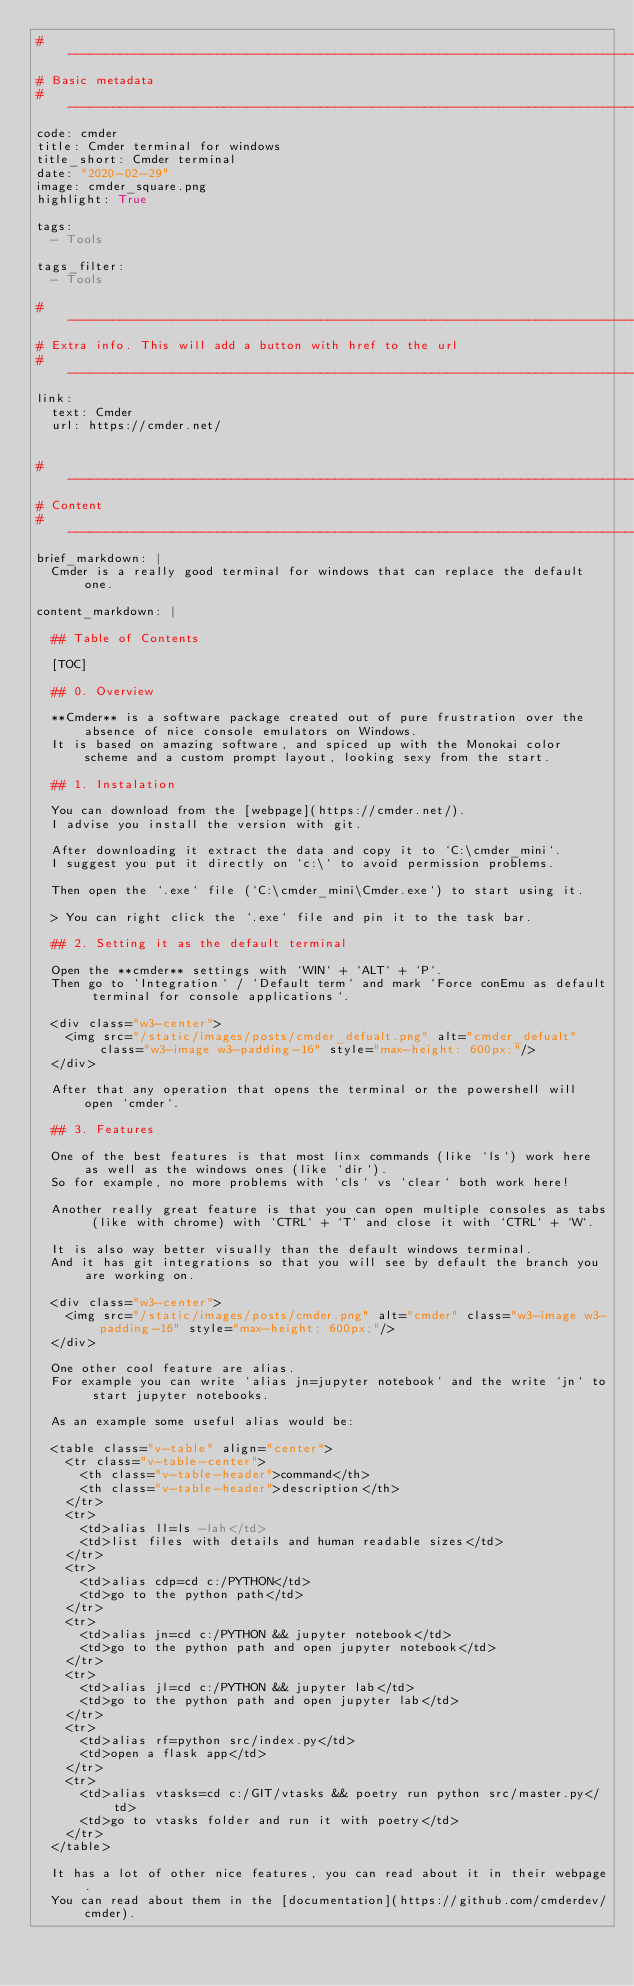Convert code to text. <code><loc_0><loc_0><loc_500><loc_500><_YAML_># --------------------------------------------------------------------------------------------------
# Basic metadata
# --------------------------------------------------------------------------------------------------
code: cmder
title: Cmder terminal for windows
title_short: Cmder terminal
date: "2020-02-29"
image: cmder_square.png
highlight: True

tags:
  - Tools

tags_filter:
  - Tools

# --------------------------------------------------------------------------------------------------
# Extra info. This will add a button with href to the url
# --------------------------------------------------------------------------------------------------
link: 
  text: Cmder
  url: https://cmder.net/


# --------------------------------------------------------------------------------------------------
# Content
# --------------------------------------------------------------------------------------------------
brief_markdown: |
  Cmder is a really good terminal for windows that can replace the default one.

content_markdown: |

  ## Table of Contents

  [TOC]

  ## 0. Overview
  
  **Cmder** is a software package created out of pure frustration over the absence of nice console emulators on Windows.
  It is based on amazing software, and spiced up with the Monokai color scheme and a custom prompt layout, looking sexy from the start.

  ## 1. Instalation

  You can download from the [webpage](https://cmder.net/).
  I advise you install the version with git.

  After downloading it extract the data and copy it to `C:\cmder_mini`.
  I suggest you put it directly on `c:\` to avoid permission problems.

  Then open the `.exe` file (`C:\cmder_mini\Cmder.exe`) to start using it.

  > You can right click the `.exe` file and pin it to the task bar.

  ## 2. Setting it as the default terminal

  Open the **cmder** settings with `WIN` + `ALT` + `P`.
  Then go to `Integration` / `Default term` and mark `Force conEmu as default terminal for console applications`.

  <div class="w3-center">
    <img src="/static/images/posts/cmder_defualt.png" alt="cmder_defualt" class="w3-image w3-padding-16" style="max-height: 600px;"/>
  </div>

  After that any operation that opens the terminal or the powershell will open `cmder`.

  ## 3. Features

  One of the best features is that most linx commands (like `ls`) work here as well as the windows ones (like `dir`).
  So for example, no more problems with `cls` vs `clear` both work here!

  Another really great feature is that you can open multiple consoles as tabs (like with chrome) with `CTRL` + `T` and close it with `CTRL` + `W`.

  It is also way better visually than the default windows terminal.
  And it has git integrations so that you will see by default the branch you are working on.

  <div class="w3-center">
    <img src="/static/images/posts/cmder.png" alt="cmder" class="w3-image w3-padding-16" style="max-height: 600px;"/>
  </div>

  One other cool feature are alias.
  For example you can write `alias jn=jupyter notebook` and the write `jn` to start jupyter notebooks.

  As an example some useful alias would be:

  <table class="v-table" align="center">
    <tr class="v-table-center">
      <th class="v-table-header">command</th>
      <th class="v-table-header">description</th>
    </tr>
    <tr>
      <td>alias ll=ls -lah</td>
      <td>list files with details and human readable sizes</td>
    </tr>
    <tr>
      <td>alias cdp=cd c:/PYTHON</td>
      <td>go to the python path</td>
    </tr>
    <tr>
      <td>alias jn=cd c:/PYTHON && jupyter notebook</td>
      <td>go to the python path and open jupyter notebook</td>
    </tr>
    <tr>
      <td>alias jl=cd c:/PYTHON && jupyter lab</td>
      <td>go to the python path and open jupyter lab</td>
    </tr>
    <tr>
      <td>alias rf=python src/index.py</td>
      <td>open a flask app</td>
    </tr>
    <tr>
      <td>alias vtasks=cd c:/GIT/vtasks && poetry run python src/master.py</td>
      <td>go to vtasks folder and run it with poetry</td>
    </tr>
  </table>

  It has a lot of other nice features, you can read about it in their webpage.
  You can read about them in the [documentation](https://github.com/cmderdev/cmder).
</code> 